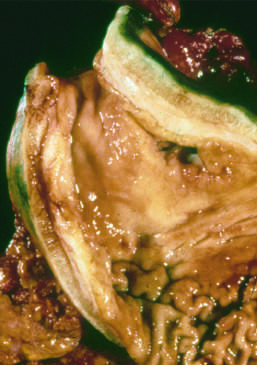s the gastric wall markedly thickened?
Answer the question using a single word or phrase. Yes 